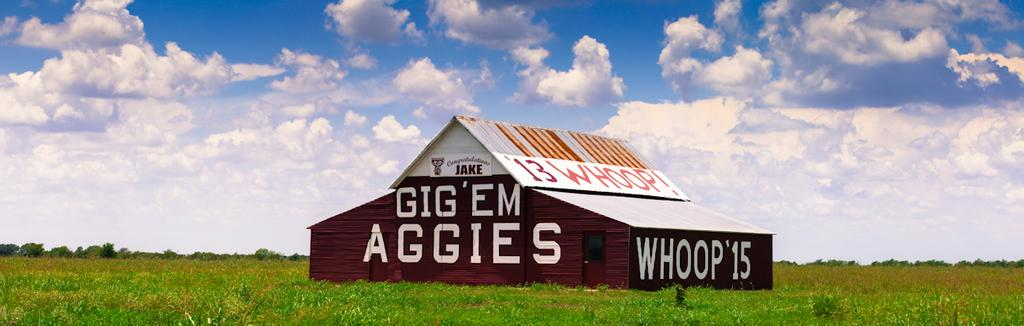What is the main subject in the center of the image? There is a house in the center of the image. What type of vegetation is at the bottom of the image? There is grass at the bottom of the image. What can be seen in the background of the image? There are plants in the background of the image. What is visible at the top of the image? The sky is visible at the top of the image. What is written or depicted on the house? There is text on the house. How many brothers are depicted playing with the goose in the image? There are no brothers or goose present in the image. What type of movement is shown in the image? The image does not depict any movement; it is a still image. 